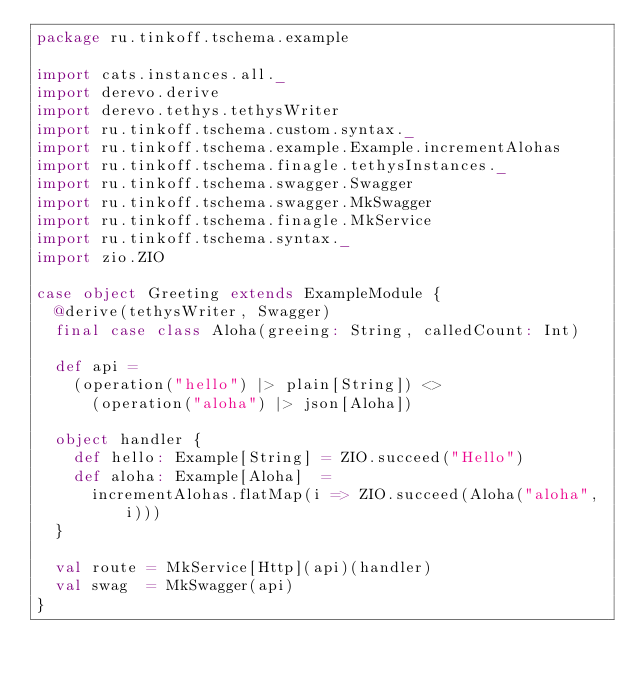Convert code to text. <code><loc_0><loc_0><loc_500><loc_500><_Scala_>package ru.tinkoff.tschema.example

import cats.instances.all._
import derevo.derive
import derevo.tethys.tethysWriter
import ru.tinkoff.tschema.custom.syntax._
import ru.tinkoff.tschema.example.Example.incrementAlohas
import ru.tinkoff.tschema.finagle.tethysInstances._
import ru.tinkoff.tschema.swagger.Swagger
import ru.tinkoff.tschema.swagger.MkSwagger
import ru.tinkoff.tschema.finagle.MkService
import ru.tinkoff.tschema.syntax._
import zio.ZIO

case object Greeting extends ExampleModule {
  @derive(tethysWriter, Swagger)
  final case class Aloha(greeing: String, calledCount: Int)

  def api =
    (operation("hello") |> plain[String]) <>
      (operation("aloha") |> json[Aloha])

  object handler {
    def hello: Example[String] = ZIO.succeed("Hello")
    def aloha: Example[Aloha]  =
      incrementAlohas.flatMap(i => ZIO.succeed(Aloha("aloha", i)))
  }

  val route = MkService[Http](api)(handler)
  val swag  = MkSwagger(api)
}
</code> 